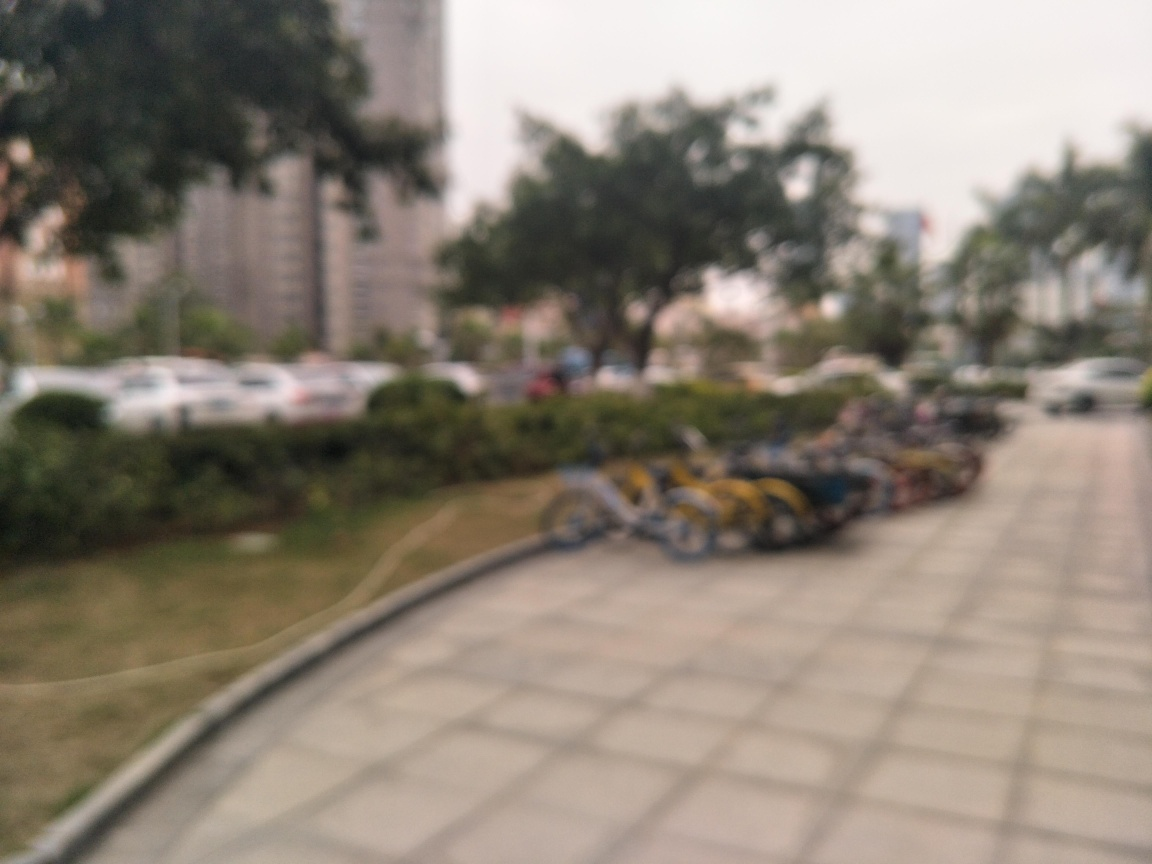What might be the reasons for using a blurred effect in this image? A blurred effect can be used artistically to create a sense of movement or dreaminess, or to focus the viewer's attention on a specific part of the image. In some cases, it could also be an unintended result of an error in focusing the camera. 